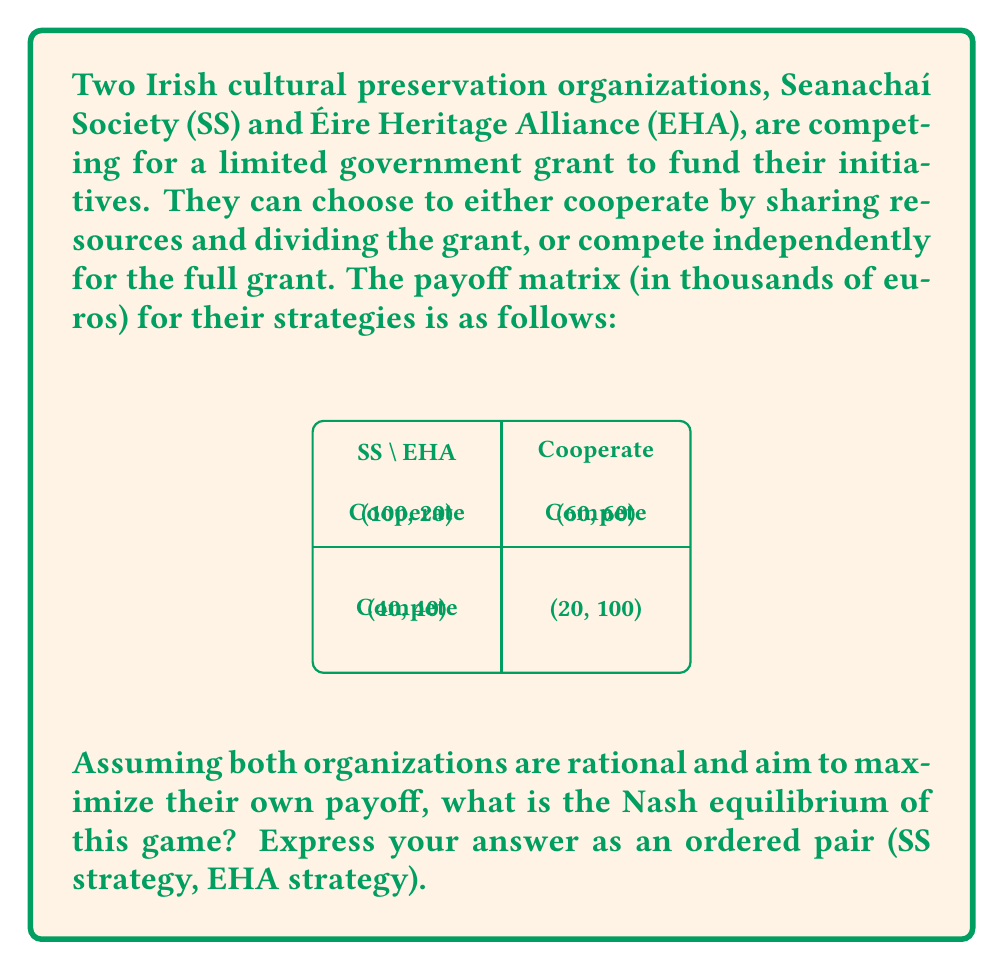Give your solution to this math problem. To find the Nash equilibrium, we need to analyze each organization's best response to the other's strategy:

1. For Seanachaí Society (SS):
   - If EHA cooperates: SS gets 60 if cooperating, 100 if competing. Best response: Compete.
   - If EHA competes: SS gets 20 if cooperating, 40 if competing. Best response: Compete.

2. For Éire Heritage Alliance (EHA):
   - If SS cooperates: EHA gets 60 if cooperating, 100 if competing. Best response: Compete.
   - If SS competes: EHA gets 20 if cooperating, 40 if competing. Best response: Compete.

The Nash equilibrium is a situation where each player is making the best decision for themselves, given what the other player is doing. In this case, regardless of what the other organization does, both SS and EHA always prefer to compete.

We can represent this mathematically:

Let $s_i \in \{C, D\}$ be the strategy of player $i$, where $C$ represents Cooperate and $D$ represents Compete (Defect).

The payoff function for SS can be written as:

$$u_{SS}(s_{SS}, s_{EHA}) = \begin{cases}
60 & \text{if } (s_{SS}, s_{EHA}) = (C, C) \\
100 & \text{if } (s_{SS}, s_{EHA}) = (D, C) \\
20 & \text{if } (s_{SS}, s_{EHA}) = (C, D) \\
40 & \text{if } (s_{SS}, s_{EHA}) = (D, D)
\end{cases}$$

Similarly for EHA:

$$u_{EHA}(s_{SS}, s_{EHA}) = \begin{cases}
60 & \text{if } (s_{SS}, s_{EHA}) = (C, C) \\
20 & \text{if } (s_{SS}, s_{EHA}) = (D, C) \\
100 & \text{if } (s_{SS}, s_{EHA}) = (C, D) \\
40 & \text{if } (s_{SS}, s_{EHA}) = (D, D)
\end{cases}$$

The Nash equilibrium $(s_{SS}^*, s_{EHA}^*)$ satisfies:

$$u_{SS}(s_{SS}^*, s_{EHA}^*) \geq u_{SS}(s_{SS}, s_{EHA}^*) \quad \forall s_{SS}$$
$$u_{EHA}(s_{SS}^*, s_{EHA}^*) \geq u_{EHA}(s_{SS}^*, s_{EHA}) \quad \forall s_{EHA}$$

These conditions are only satisfied when both organizations choose to compete (D, D).

Therefore, the Nash equilibrium of this game is (Compete, Compete).
Answer: (Compete, Compete) 